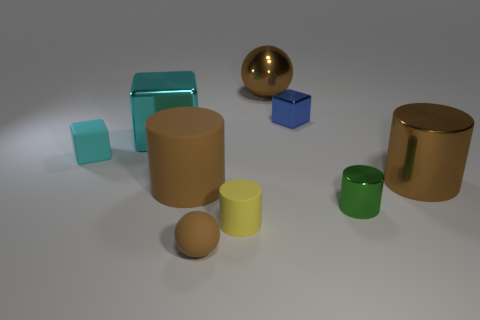Subtract all blocks. How many objects are left? 6 Add 5 small cyan things. How many small cyan things exist? 6 Subtract 0 purple cubes. How many objects are left? 9 Subtract all small yellow matte objects. Subtract all balls. How many objects are left? 6 Add 5 yellow cylinders. How many yellow cylinders are left? 6 